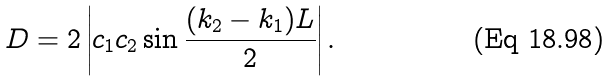Convert formula to latex. <formula><loc_0><loc_0><loc_500><loc_500>D = 2 \left | c _ { 1 } c _ { 2 } \sin { \frac { ( k _ { 2 } - k _ { 1 } ) L } { 2 } } \right | .</formula> 